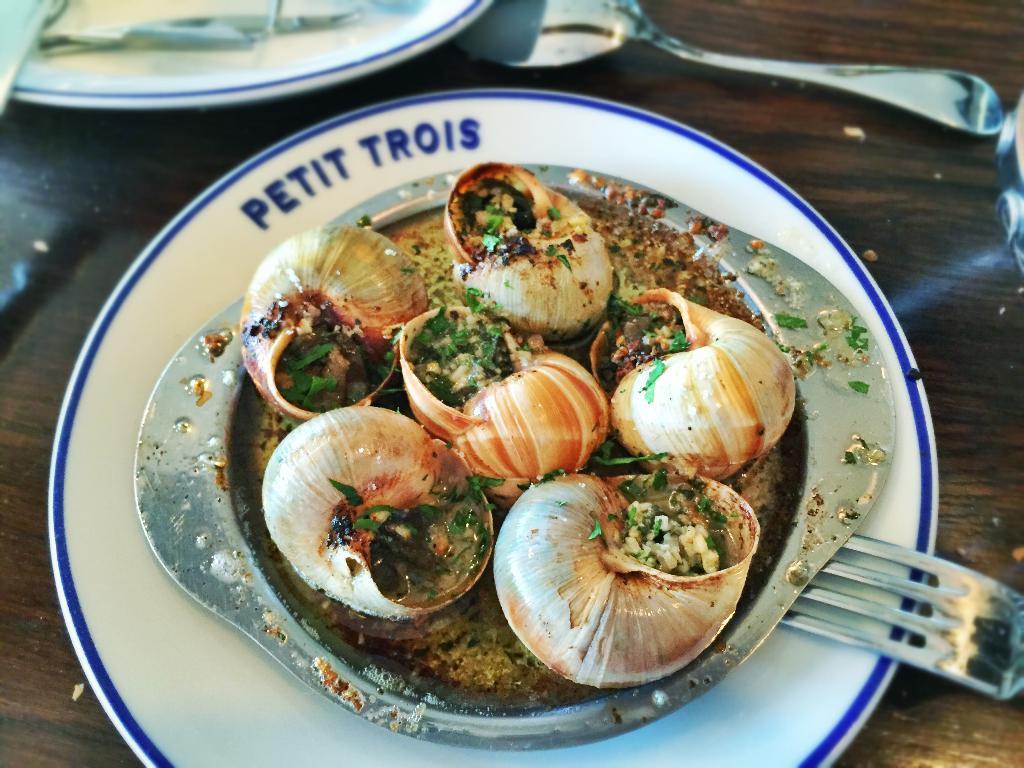Please provide a concise description of this image. In this image I can see a brown colored surface on which I can see few spoons, few forks and two plates. On the plate I can see a bowl with few shells and few herbs on them. 